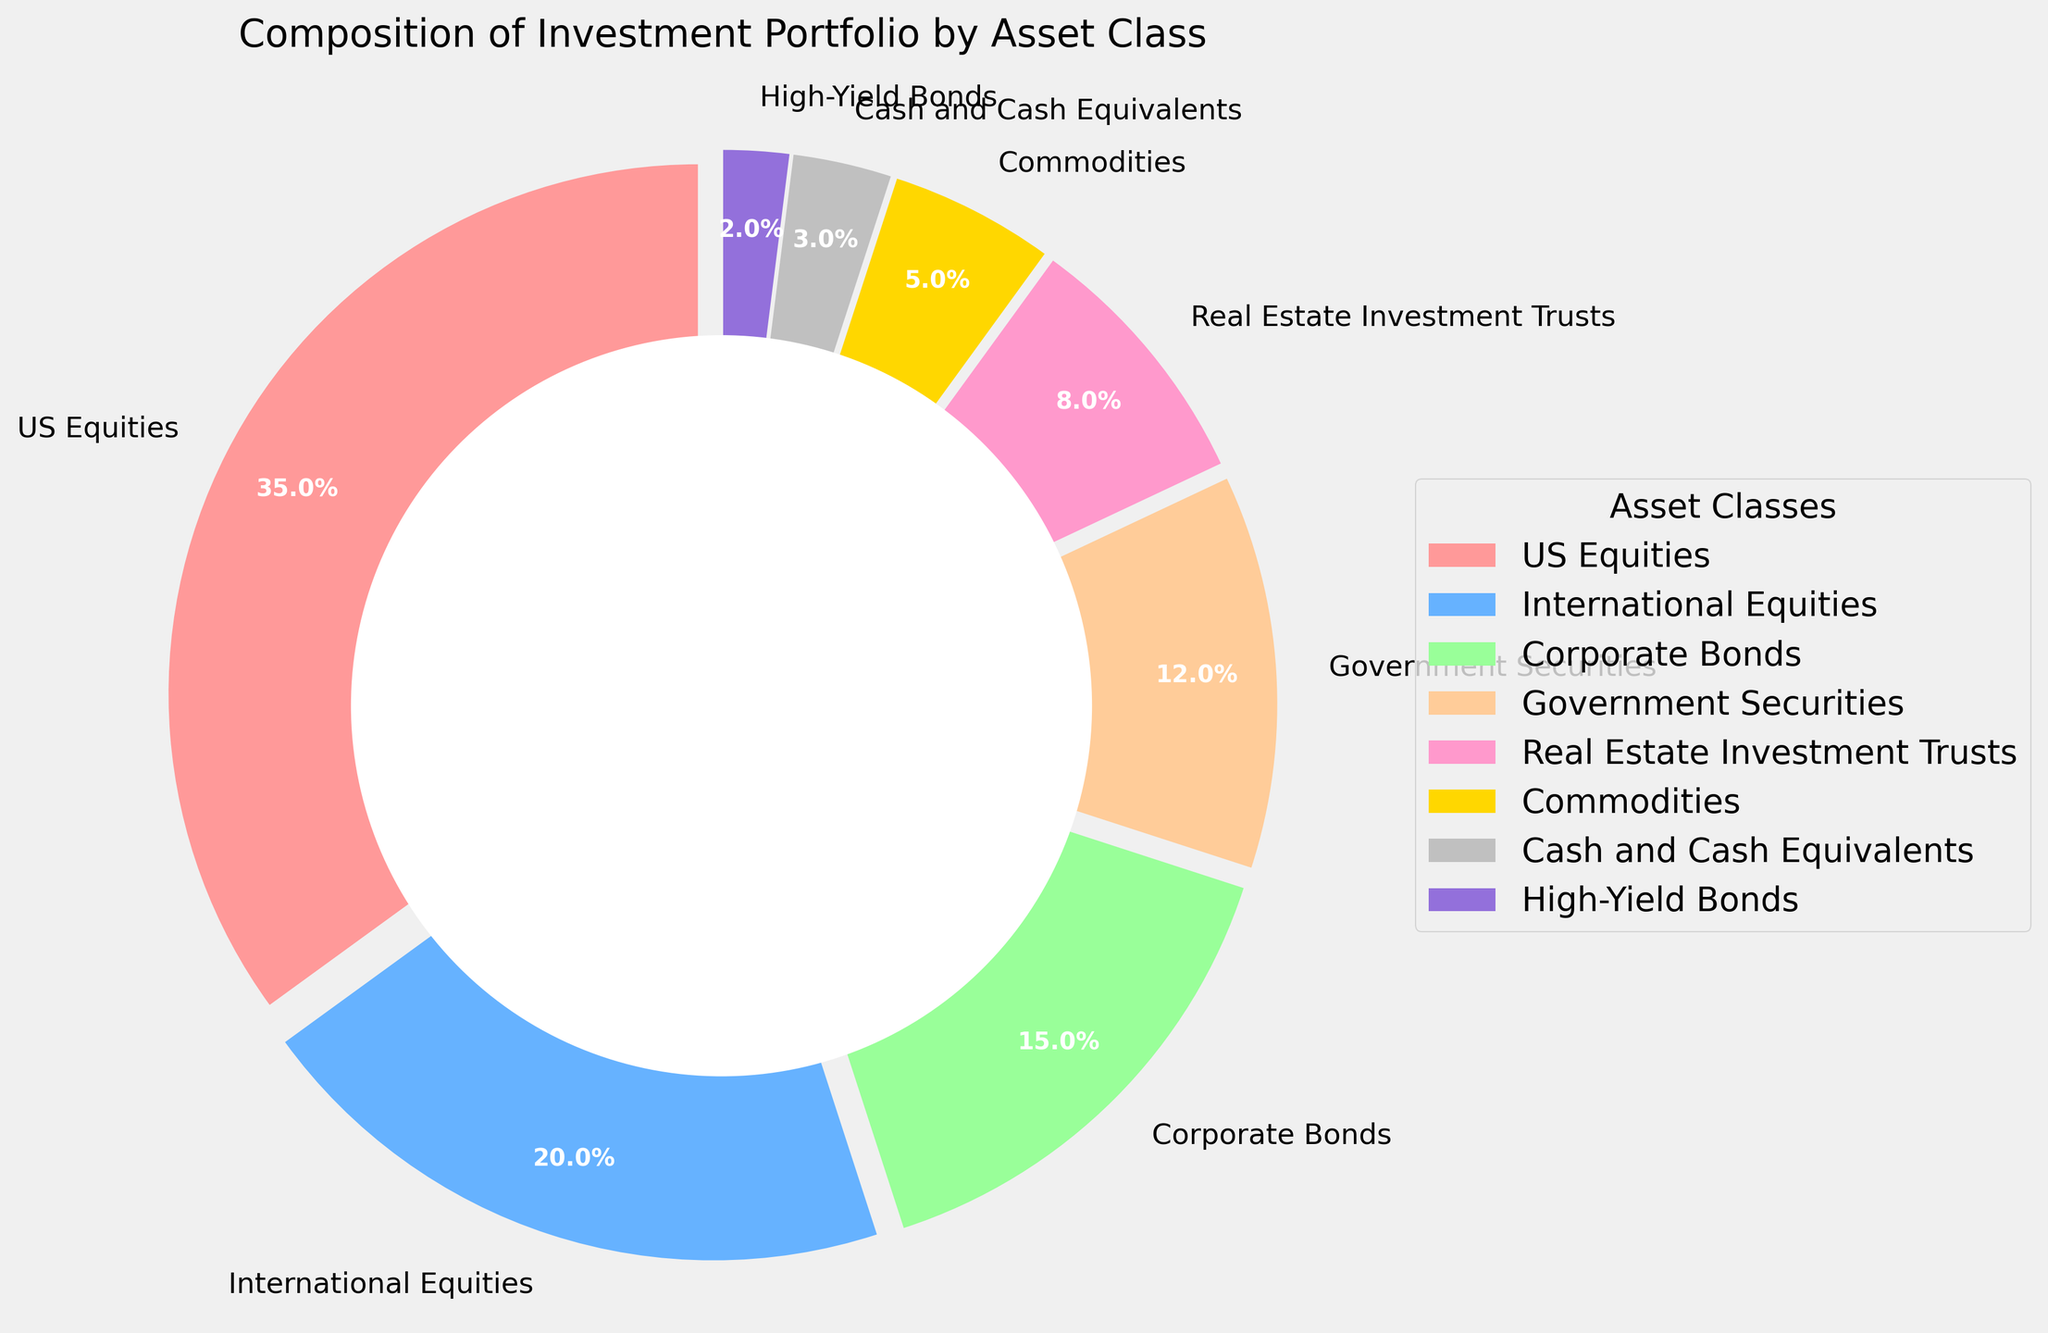What is the largest asset class in the company's investment portfolio? By looking at the pie chart, the slice for US Equities is the largest, taking up the most space.
Answer: US Equities What is the combined percentage of US Equities and International Equities? US Equities account for 35%, and International Equities account for 20%. Adding these together, 35% + 20% = 55%.
Answer: 55% Which asset class has a higher percentage, Corporate Bonds or Government Securities? By comparing the slices for Corporate Bonds and Government Securities, Corporate Bonds is larger, indicating a higher percentage.
Answer: Corporate Bonds What's the difference in percentage between Real Estate Investment Trusts and Commodities? Real Estate Investment Trusts make up 8%, while Commodities make up 5%. The difference is 8% - 5% = 3%.
Answer: 3% Which asset class has the smallest representation in the investment portfolio? The slice for High-Yield Bonds is the smallest in the pie chart, indicating it has the smallest percentage.
Answer: High-Yield Bonds What's the combined percentage of all asset classes except US Equities? Add the percentages of all asset classes except US Equities: 20% (International Equities) + 15% (Corporate Bonds) + 12% (Government Securities) + 8% (Real Estate Investment Trusts) + 5% (Commodities) + 3% (Cash and Cash Equivalents) + 2% (High-Yield Bonds) = 65%.
Answer: 65% Are there more Government Securities or Real Estate Investment Trusts in the portfolio? By comparing their respective slices, Government Securities (12%) make up a larger portion than Real Estate Investment Trusts (8%).
Answer: Government Securities What is the total percentage of various Bonds in the portfolio (Corporate and High-Yield Bonds included)? Sum the percentages of Corporate Bonds (15%) and High-Yield Bonds (2%): 15% + 2% = 17%.
Answer: 17% Which color represents International Equities on the pie chart? The slice for International Equities is blue.
Answer: Blue Is the percentage of Cash and Cash Equivalents greater than Commodities? No, Cash and Cash Equivalents make up 3% of the portfolio, while Commodities make up 5%.
Answer: No 